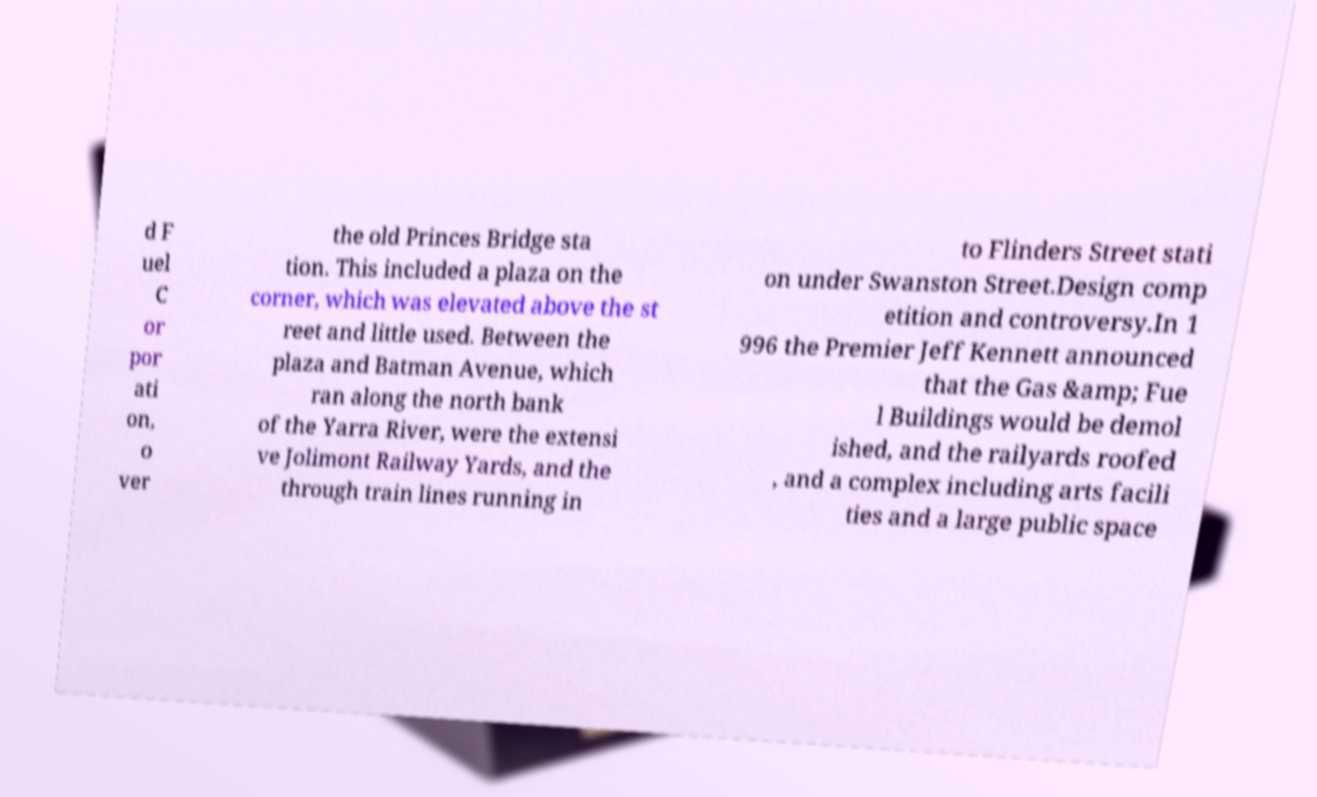Could you extract and type out the text from this image? d F uel C or por ati on, o ver the old Princes Bridge sta tion. This included a plaza on the corner, which was elevated above the st reet and little used. Between the plaza and Batman Avenue, which ran along the north bank of the Yarra River, were the extensi ve Jolimont Railway Yards, and the through train lines running in to Flinders Street stati on under Swanston Street.Design comp etition and controversy.In 1 996 the Premier Jeff Kennett announced that the Gas &amp; Fue l Buildings would be demol ished, and the railyards roofed , and a complex including arts facili ties and a large public space 